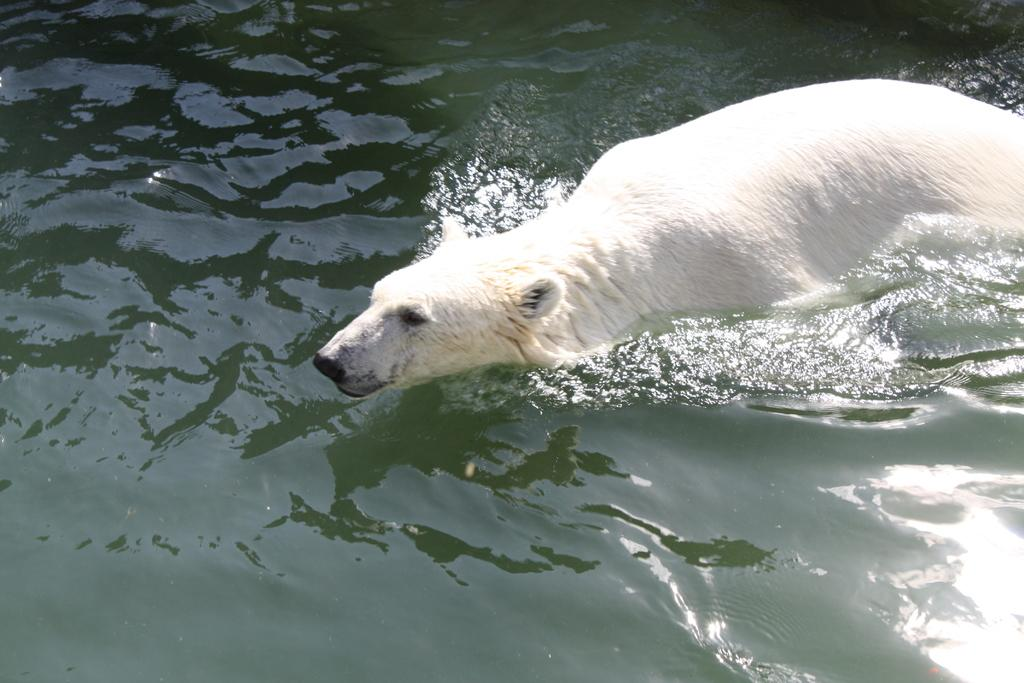What animal is in the image? There is a polar bear in the image. What is the polar bear doing in the image? The polar bear is swimming in the water. What type of twig is the polar bear holding in its mouth in the image? There is no twig present in the image; the polar bear is swimming in the water. 